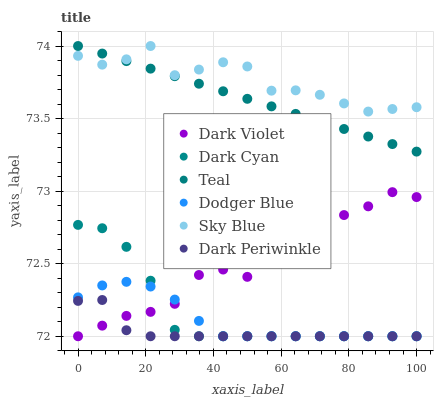Does Dark Periwinkle have the minimum area under the curve?
Answer yes or no. Yes. Does Sky Blue have the maximum area under the curve?
Answer yes or no. Yes. Does Dodger Blue have the minimum area under the curve?
Answer yes or no. No. Does Dodger Blue have the maximum area under the curve?
Answer yes or no. No. Is Teal the smoothest?
Answer yes or no. Yes. Is Dark Violet the roughest?
Answer yes or no. Yes. Is Dodger Blue the smoothest?
Answer yes or no. No. Is Dodger Blue the roughest?
Answer yes or no. No. Does Dark Violet have the lowest value?
Answer yes or no. Yes. Does Teal have the lowest value?
Answer yes or no. No. Does Sky Blue have the highest value?
Answer yes or no. Yes. Does Dodger Blue have the highest value?
Answer yes or no. No. Is Dodger Blue less than Teal?
Answer yes or no. Yes. Is Teal greater than Dark Periwinkle?
Answer yes or no. Yes. Does Dark Violet intersect Dodger Blue?
Answer yes or no. Yes. Is Dark Violet less than Dodger Blue?
Answer yes or no. No. Is Dark Violet greater than Dodger Blue?
Answer yes or no. No. Does Dodger Blue intersect Teal?
Answer yes or no. No. 